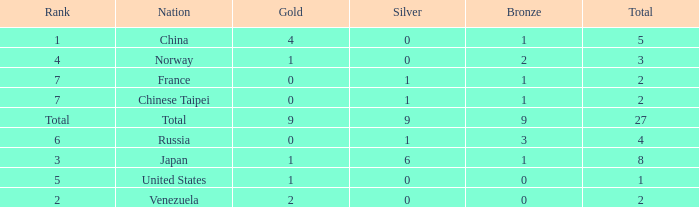What is the total number of Bronze when gold is more than 1 and nation is total? 1.0. 